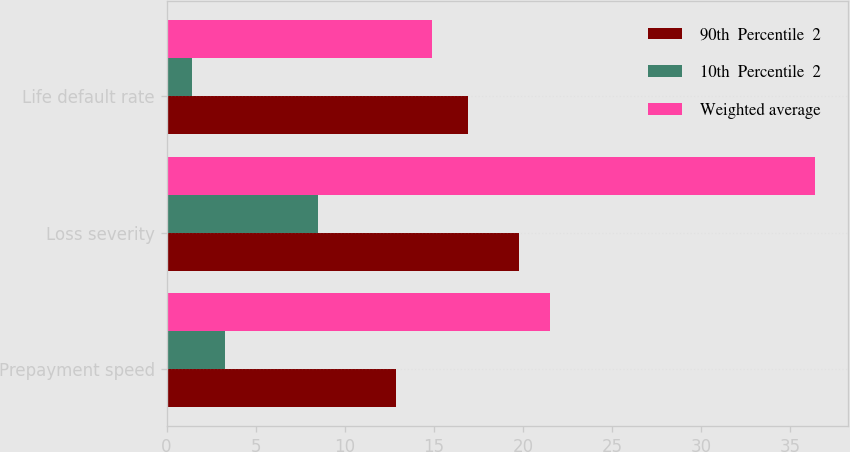Convert chart to OTSL. <chart><loc_0><loc_0><loc_500><loc_500><stacked_bar_chart><ecel><fcel>Prepayment speed<fcel>Loss severity<fcel>Life default rate<nl><fcel>90th  Percentile  2<fcel>12.9<fcel>19.8<fcel>16.9<nl><fcel>10th  Percentile  2<fcel>3.3<fcel>8.5<fcel>1.4<nl><fcel>Weighted average<fcel>21.5<fcel>36.4<fcel>14.9<nl></chart> 